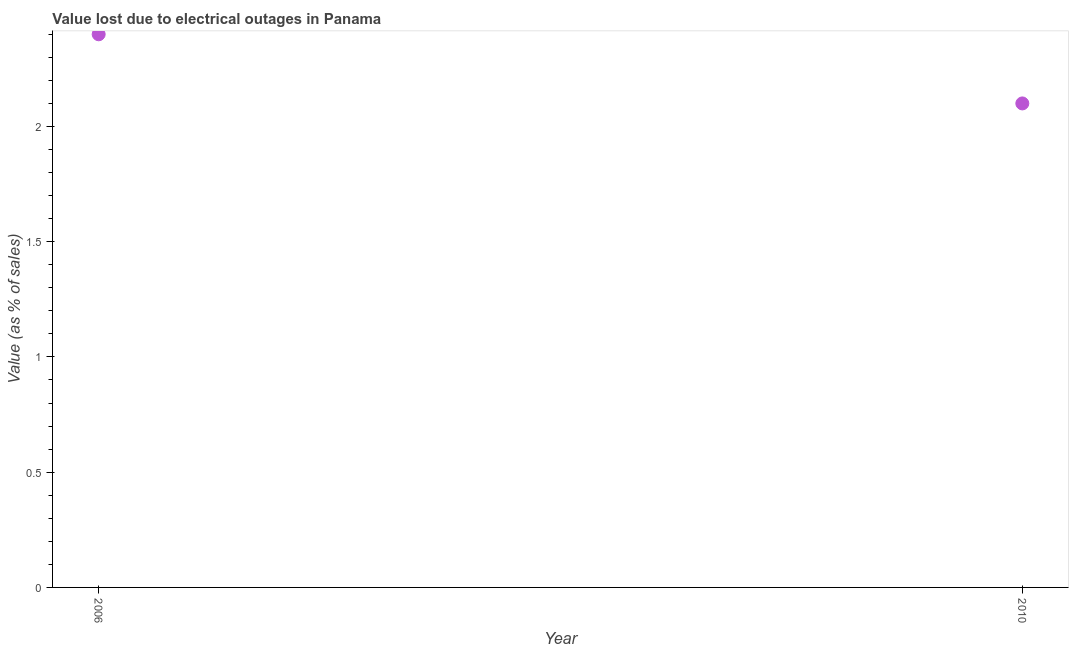What is the value lost due to electrical outages in 2006?
Give a very brief answer. 2.4. In which year was the value lost due to electrical outages maximum?
Your response must be concise. 2006. In which year was the value lost due to electrical outages minimum?
Give a very brief answer. 2010. What is the sum of the value lost due to electrical outages?
Provide a succinct answer. 4.5. What is the difference between the value lost due to electrical outages in 2006 and 2010?
Make the answer very short. 0.3. What is the average value lost due to electrical outages per year?
Provide a succinct answer. 2.25. What is the median value lost due to electrical outages?
Your answer should be very brief. 2.25. What is the ratio of the value lost due to electrical outages in 2006 to that in 2010?
Offer a very short reply. 1.14. What is the difference between two consecutive major ticks on the Y-axis?
Keep it short and to the point. 0.5. What is the title of the graph?
Make the answer very short. Value lost due to electrical outages in Panama. What is the label or title of the X-axis?
Give a very brief answer. Year. What is the label or title of the Y-axis?
Your response must be concise. Value (as % of sales). What is the Value (as % of sales) in 2010?
Your answer should be very brief. 2.1. What is the difference between the Value (as % of sales) in 2006 and 2010?
Provide a short and direct response. 0.3. What is the ratio of the Value (as % of sales) in 2006 to that in 2010?
Offer a terse response. 1.14. 